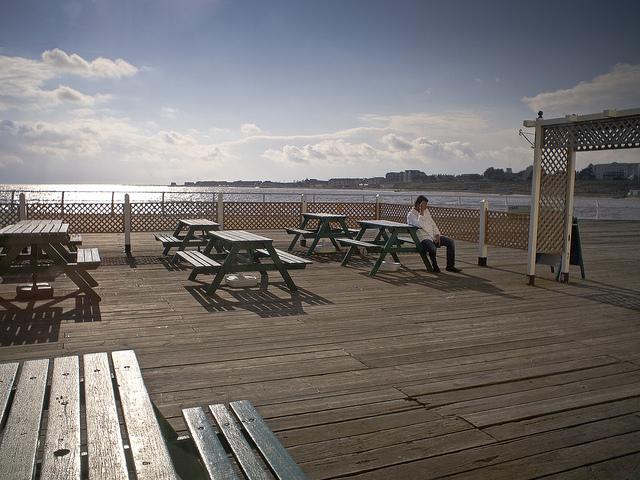How many benches are visible?
Answer briefly. 6. Where could a person take a break?
Answer briefly. Picnic table. Are the tables and the deck constructed of similar materials?
Write a very short answer. Yes. How many narrow beams make up one bench?
Keep it brief. 3. What is the ground made of?
Give a very brief answer. Wood. What is the railing made of?
Be succinct. Wood. Are these chairs all the same color?
Give a very brief answer. Yes. Are there any animals in this photo?
Write a very short answer. No. How many benches are occupied?
Be succinct. 1. Is there clouds?
Write a very short answer. Yes. How many empty picnic tables?
Quick response, please. 6. 